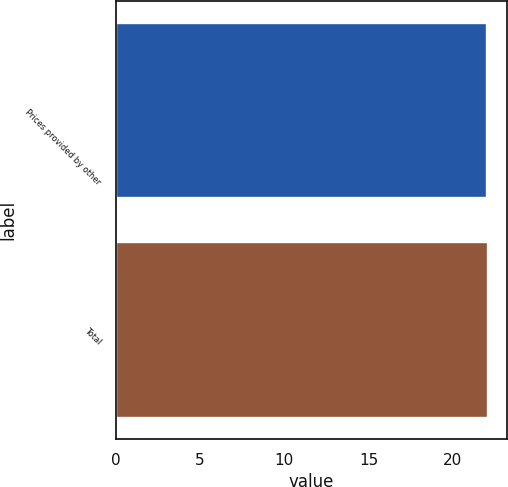<chart> <loc_0><loc_0><loc_500><loc_500><bar_chart><fcel>Prices provided by other<fcel>Total<nl><fcel>22<fcel>22.1<nl></chart> 